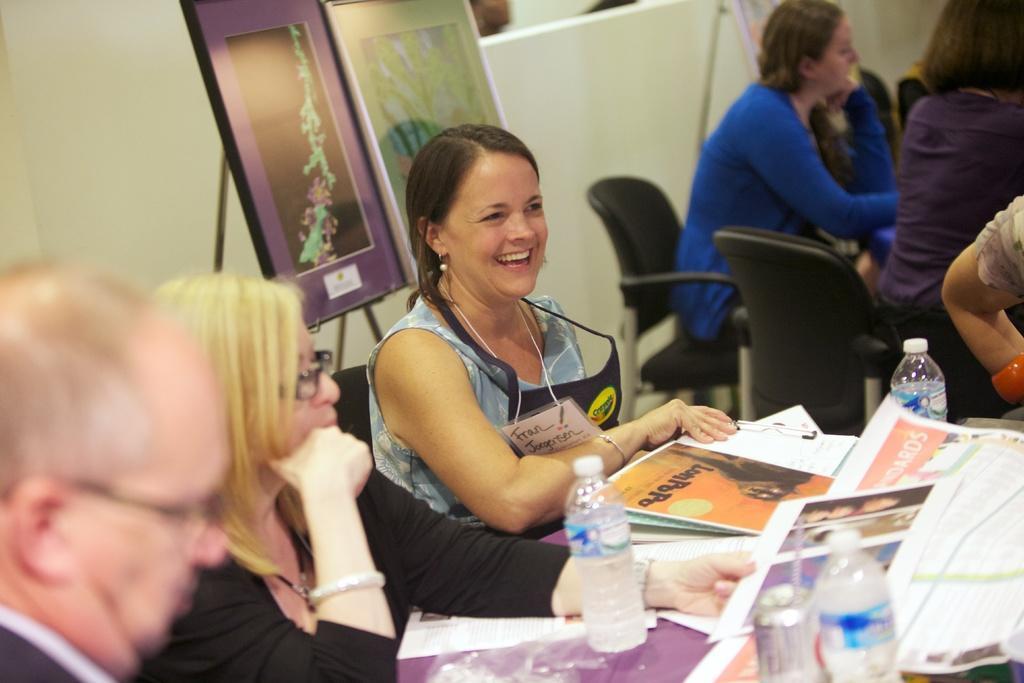In one or two sentences, can you explain what this image depicts? This is picture inside a room. There is woman wearing a apron smiling who sat on chair beside another woman who wore black dress,she had blond hair. Behind them there are two paintings and there is a table in front of people which had bottles newspapers on it and another woman sat on chair in the background. 